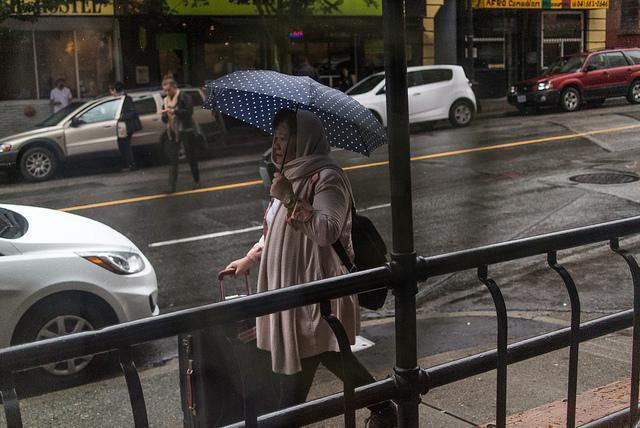How many cars are in the photo?
Give a very brief answer. 4. How many people are visible?
Give a very brief answer. 2. 